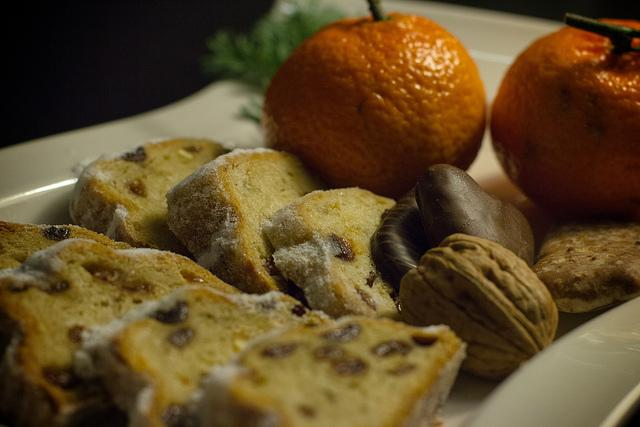What is the name of the nut on the plate?

Choices:
A) peanut
B) walnut
C) cashew
D) pistachio walnut 